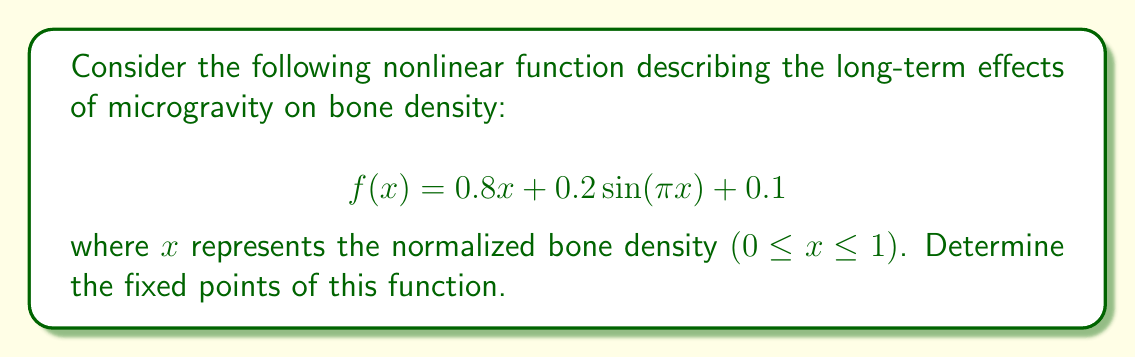Provide a solution to this math problem. To find the fixed points of the function, we need to solve the equation $f(x) = x$. This gives us:

1) Set up the equation:
   $$0.8x + 0.2\sin(\pi x) + 0.1 = x$$

2) Rearrange the equation:
   $$0.2\sin(\pi x) = 0.2x - 0.1$$

3) Divide both sides by 0.2:
   $$\sin(\pi x) = x - 0.5$$

4) This equation cannot be solved analytically. We need to use numerical methods or graphical analysis to find the solutions.

5) Graphically, we can see that this equation has two solutions in the interval [0,1]:
   
[asy]
import graph;
size(200,200);
real f(real x) {return sin(pi*x);}
real g(real x) {return x-0.5;}
draw(graph(f,0,1),blue);
draw(graph(g,0,1),red);
xaxis("x",0,1,Arrow);
yaxis("y",-0.6,0.6,Arrow);
label("y=sin(πx)",(-0.05,0.9),blue);
label("y=x-0.5",(0.95,0.4),red);
[/asy]

6) Using a numerical method (e.g., Newton's method), we can approximate these solutions:
   $x_1 \approx 0.2325$
   $x_2 \approx 0.8558$

These points represent the stable (higher value) and unstable (lower value) equilibrium bone densities under long-term microgravity exposure.
Answer: $x_1 \approx 0.2325$, $x_2 \approx 0.8558$ 